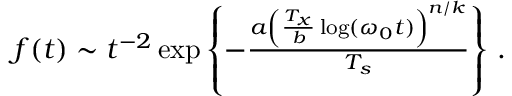Convert formula to latex. <formula><loc_0><loc_0><loc_500><loc_500>\begin{array} { r } { f ( t ) \sim t ^ { - 2 } \exp \left \{ - \frac { a \left ( \frac { T _ { x } } { b } \log ( \omega _ { 0 } t ) \right ) ^ { n / k } } { T _ { s } } \right \} \, . } \end{array}</formula> 